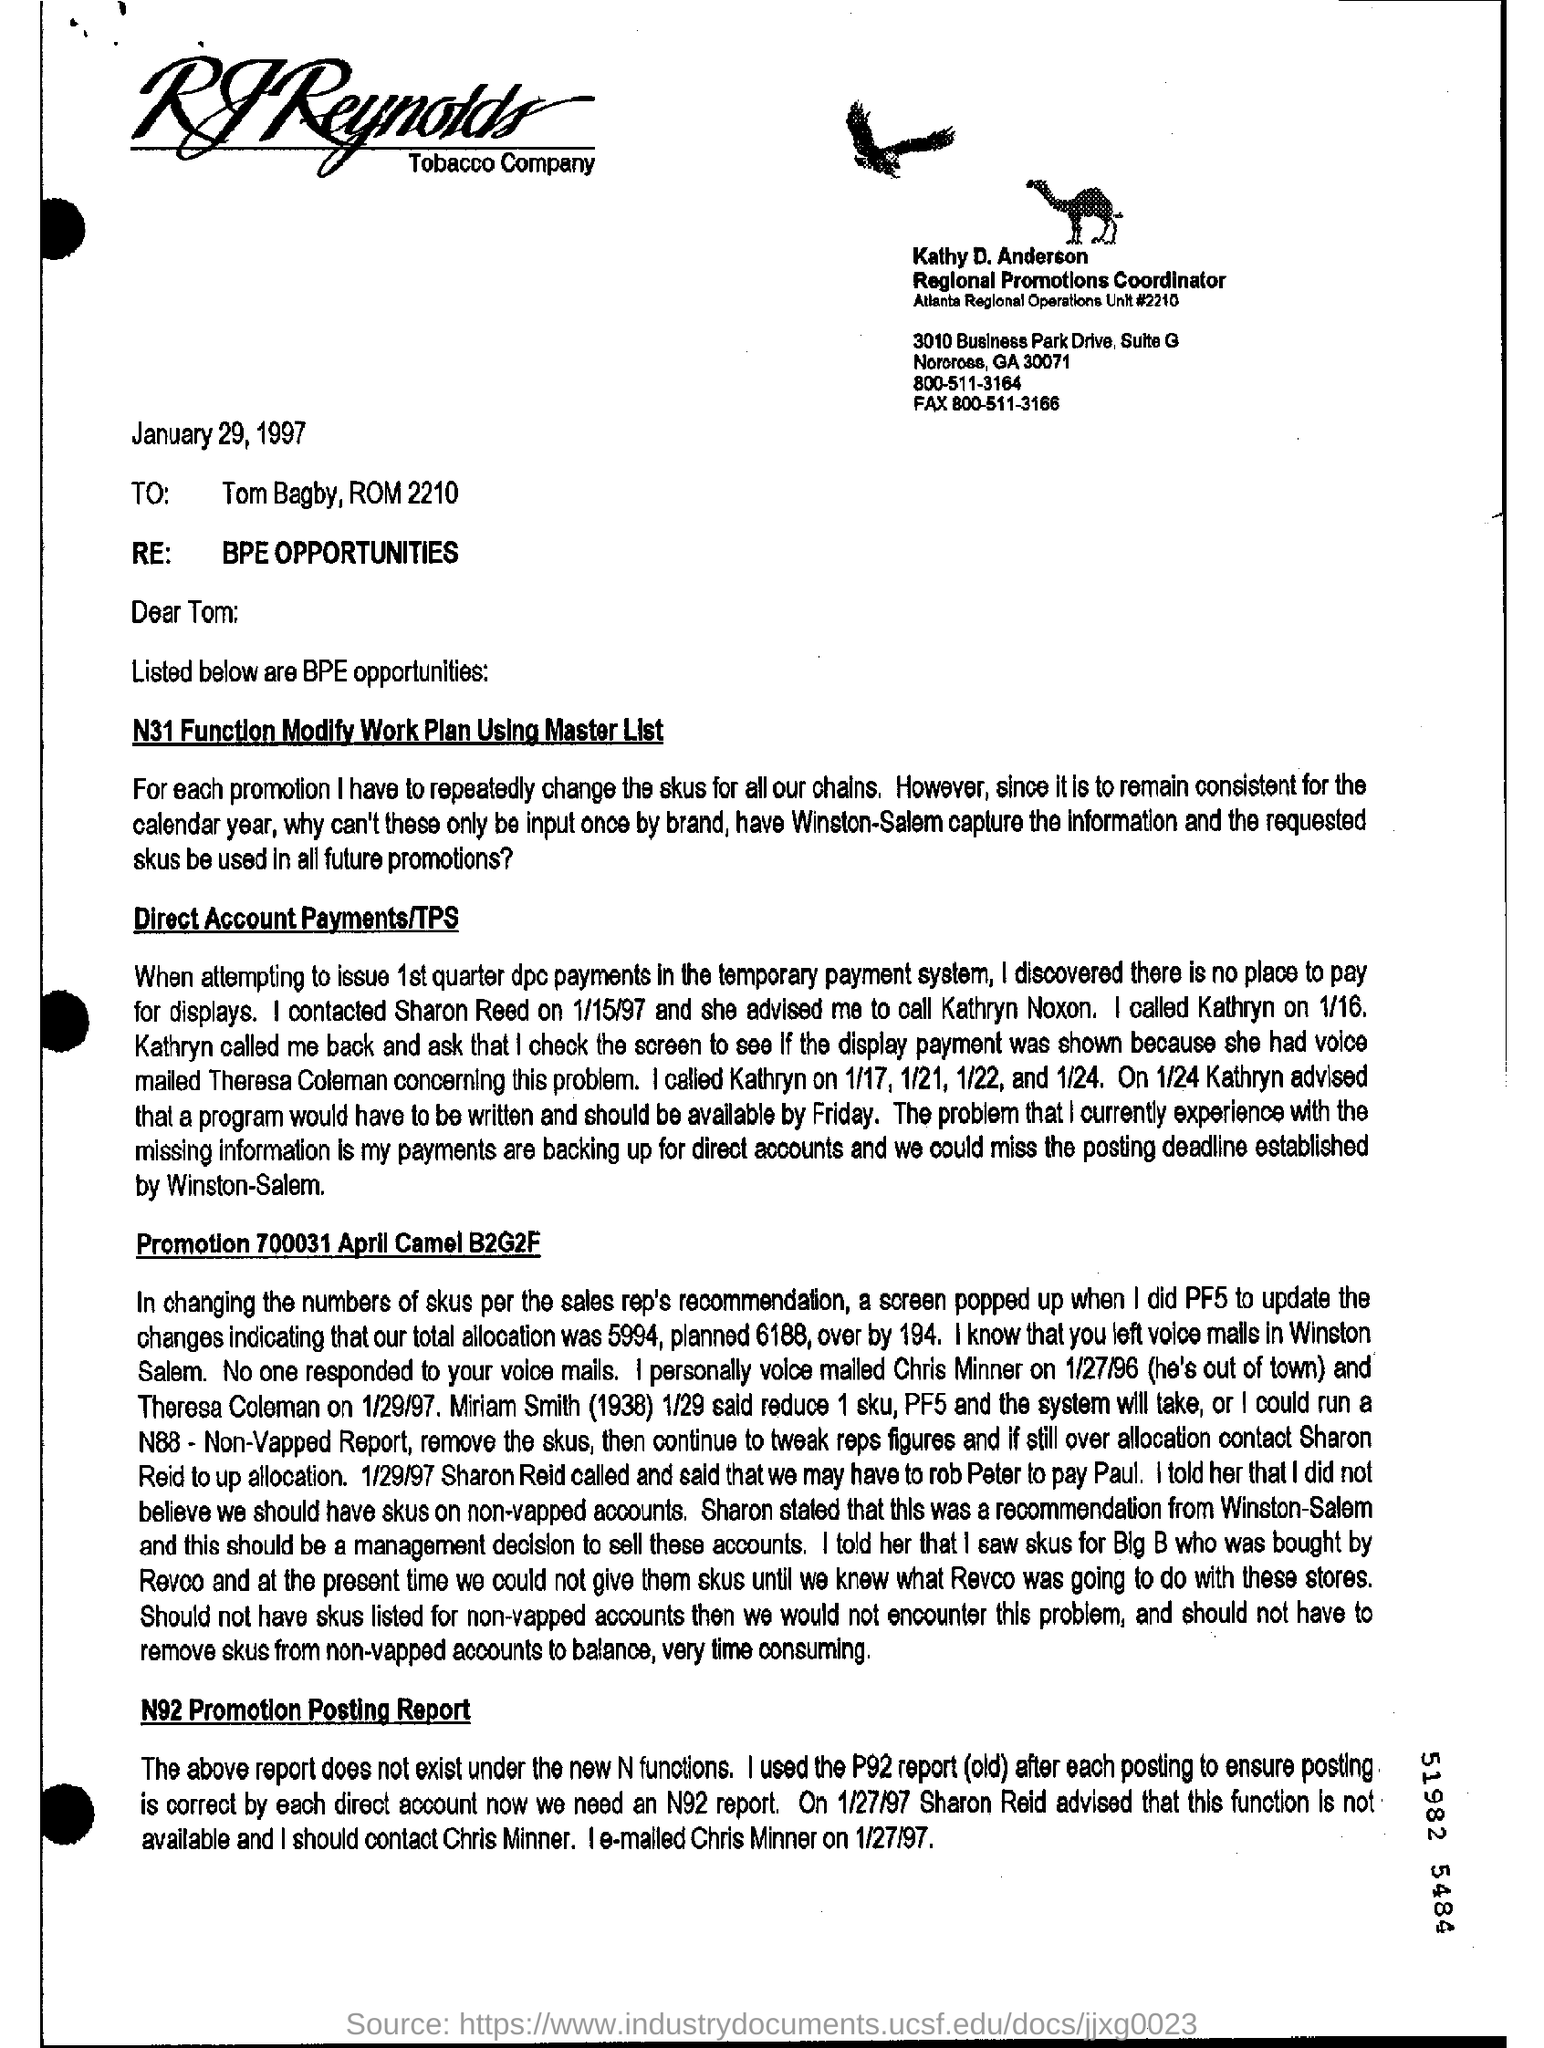List a handful of essential elements in this visual. This document is addressed to Tom Bagby, ROM 2210. The N31 Function Modify Work Plan is made using the Master list. The date mentioned is January 29, 1997. 